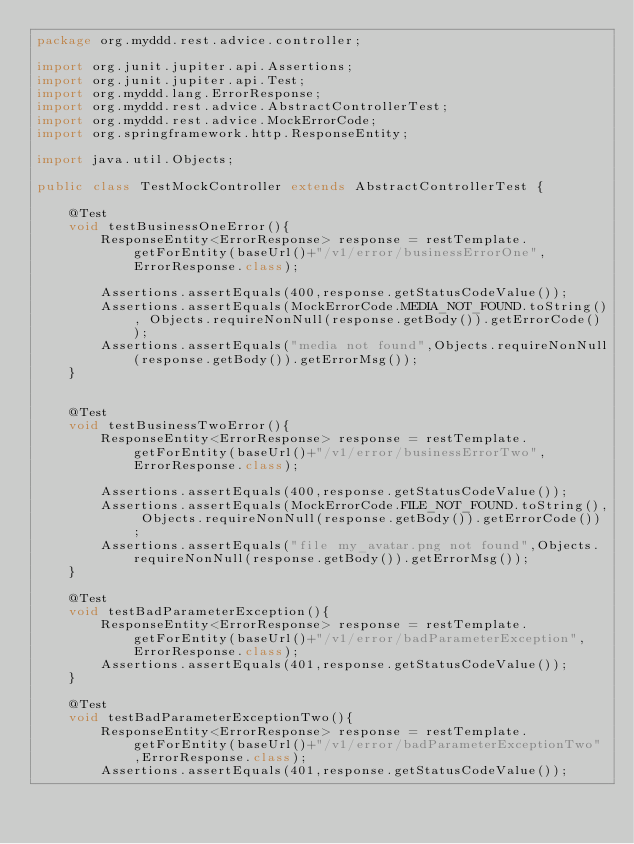<code> <loc_0><loc_0><loc_500><loc_500><_Java_>package org.myddd.rest.advice.controller;

import org.junit.jupiter.api.Assertions;
import org.junit.jupiter.api.Test;
import org.myddd.lang.ErrorResponse;
import org.myddd.rest.advice.AbstractControllerTest;
import org.myddd.rest.advice.MockErrorCode;
import org.springframework.http.ResponseEntity;

import java.util.Objects;

public class TestMockController extends AbstractControllerTest {

    @Test
    void testBusinessOneError(){
        ResponseEntity<ErrorResponse> response = restTemplate.getForEntity(baseUrl()+"/v1/error/businessErrorOne",ErrorResponse.class);

        Assertions.assertEquals(400,response.getStatusCodeValue());
        Assertions.assertEquals(MockErrorCode.MEDIA_NOT_FOUND.toString(), Objects.requireNonNull(response.getBody()).getErrorCode());
        Assertions.assertEquals("media not found",Objects.requireNonNull(response.getBody()).getErrorMsg());
    }


    @Test
    void testBusinessTwoError(){
        ResponseEntity<ErrorResponse> response = restTemplate.getForEntity(baseUrl()+"/v1/error/businessErrorTwo",ErrorResponse.class);

        Assertions.assertEquals(400,response.getStatusCodeValue());
        Assertions.assertEquals(MockErrorCode.FILE_NOT_FOUND.toString(), Objects.requireNonNull(response.getBody()).getErrorCode());
        Assertions.assertEquals("file my_avatar.png not found",Objects.requireNonNull(response.getBody()).getErrorMsg());
    }

    @Test
    void testBadParameterException(){
        ResponseEntity<ErrorResponse> response = restTemplate.getForEntity(baseUrl()+"/v1/error/badParameterException",ErrorResponse.class);
        Assertions.assertEquals(401,response.getStatusCodeValue());
    }

    @Test
    void testBadParameterExceptionTwo(){
        ResponseEntity<ErrorResponse> response = restTemplate.getForEntity(baseUrl()+"/v1/error/badParameterExceptionTwo",ErrorResponse.class);
        Assertions.assertEquals(401,response.getStatusCodeValue());</code> 